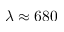<formula> <loc_0><loc_0><loc_500><loc_500>\lambda \approx 6 8 0</formula> 